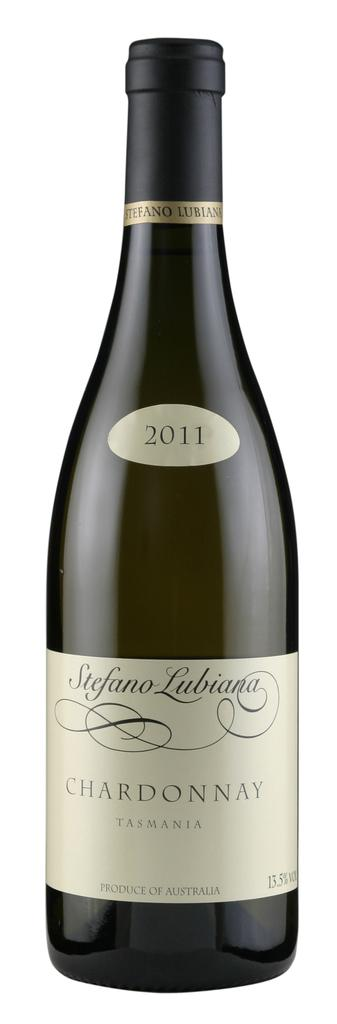<image>
Provide a brief description of the given image. new bottle of chardonnay  from 2011 sits on counter 